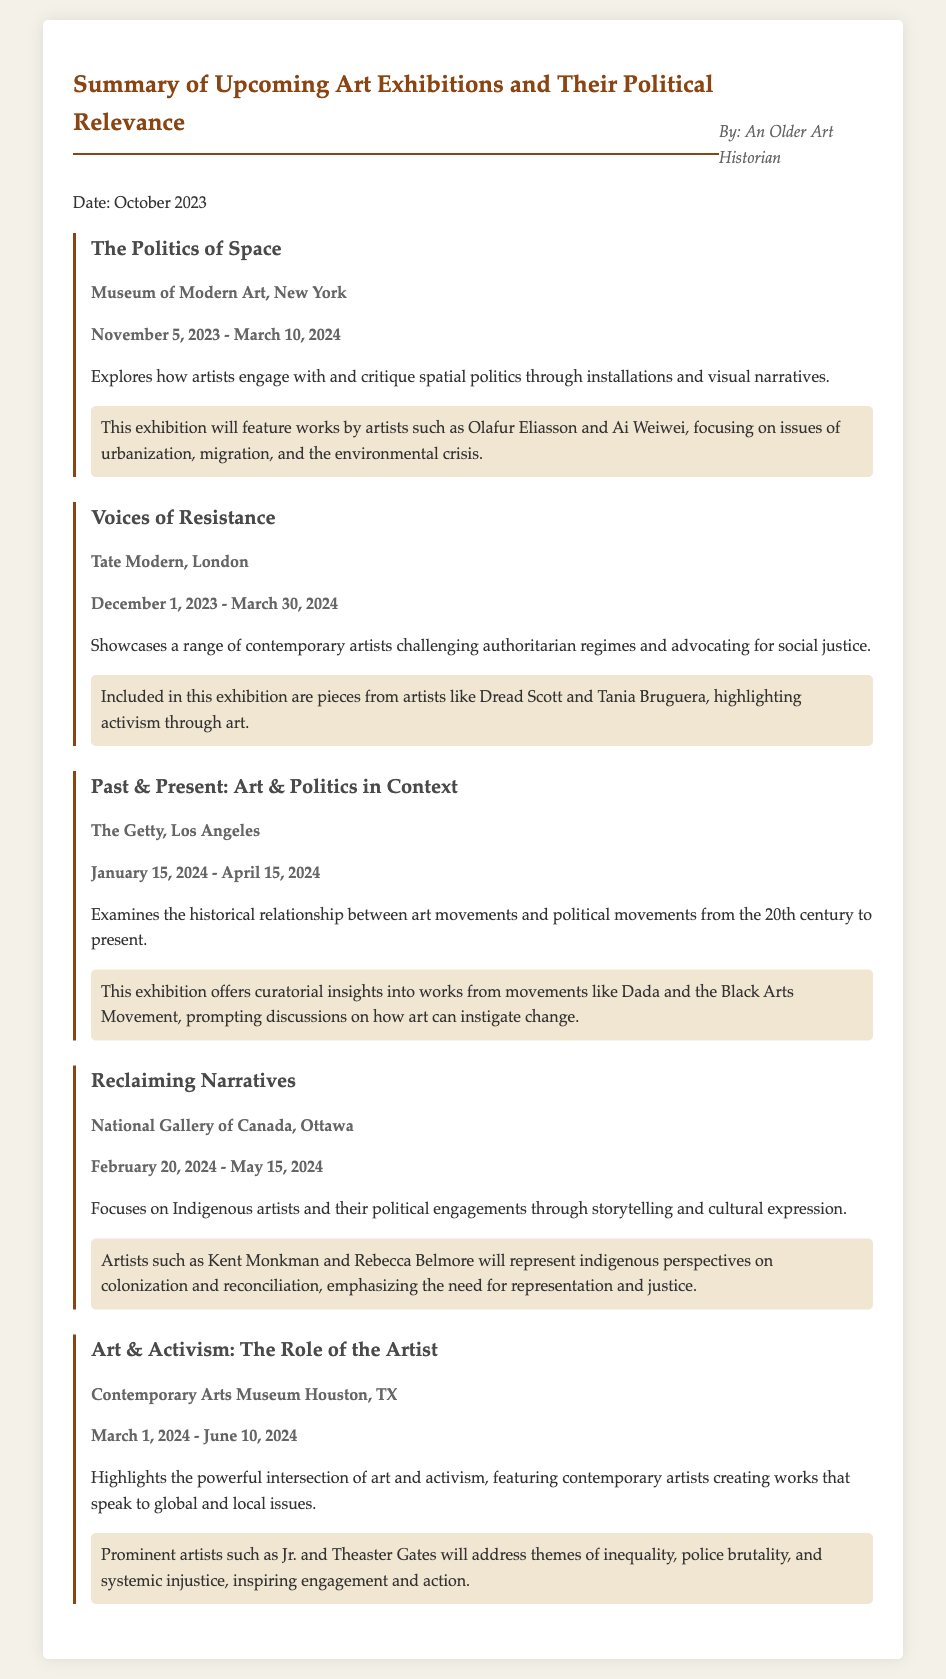what is the title of the first exhibition? The title of the first exhibition is "The Politics of Space," which is listed at the beginning of the document.
Answer: The Politics of Space where will "Voices of Resistance" be held? The location for "Voices of Resistance" is the Tate Modern, London, as specified in the exhibition details.
Answer: Tate Modern, London what are the dates for the exhibition at The Getty? The exhibition at The Getty runs from January 15, 2024, to April 15, 2024, as indicated in the document.
Answer: January 15, 2024 - April 15, 2024 which exhibition features Indigenous artists? The exhibition that features Indigenous artists is "Reclaiming Narratives," detailed in the summary.
Answer: Reclaiming Narratives how many exhibitions are covered in the document? The document lists a total of five exhibitions, as outlined in the summary section.
Answer: five what themes are explored in “Art & Activism: The Role of the Artist”? The themes explored in this exhibition focus on the powerful intersection of art and activism, as mentioned in the description.
Answer: art and activism who are two artists featured in “The Politics of Space”? The two artists featured in "The Politics of Space" are Olafur Eliasson and Ai Weiwei, according to the information provided.
Answer: Olafur Eliasson and Ai Weiwei what is the primary focus of "Past & Present: Art & Politics in Context"? The primary focus of "Past & Present: Art & Politics in Context" is the historical relationship between art movements and political movements.
Answer: historical relationship between art movements and political movements which exhibition highlights issues of inequality and police brutality? The exhibition that highlights issues of inequality and police brutality is "Art & Activism: The Role of the Artist."
Answer: Art & Activism: The Role of the Artist 